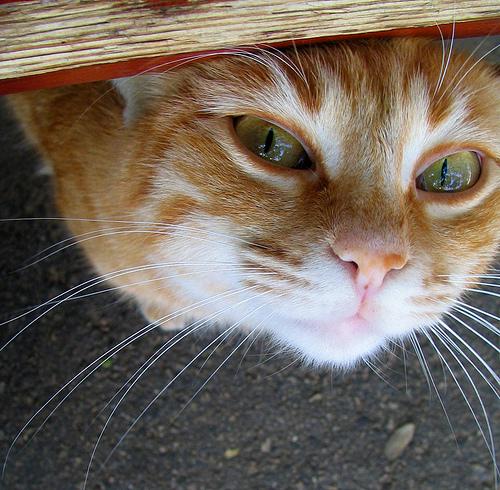Is the cat awake?
Give a very brief answer. Yes. What color is the cat?
Concise answer only. Orange. Is the cat looking up?
Concise answer only. Yes. 